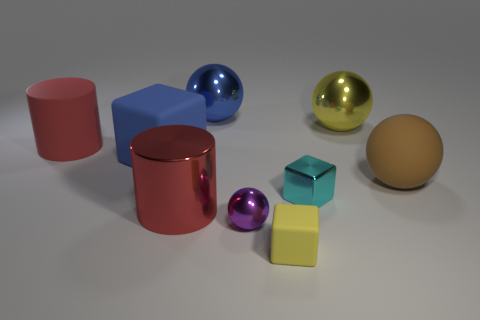What are the other shapes and colors visible in this image besides the yellow and blue spheres? Besides the yellow and blue spheres, the image features objects of various shapes including a red cylinder, a blue cube, and a tan-colored sphere. The diversity of shapes creates a visually engaging composition. 